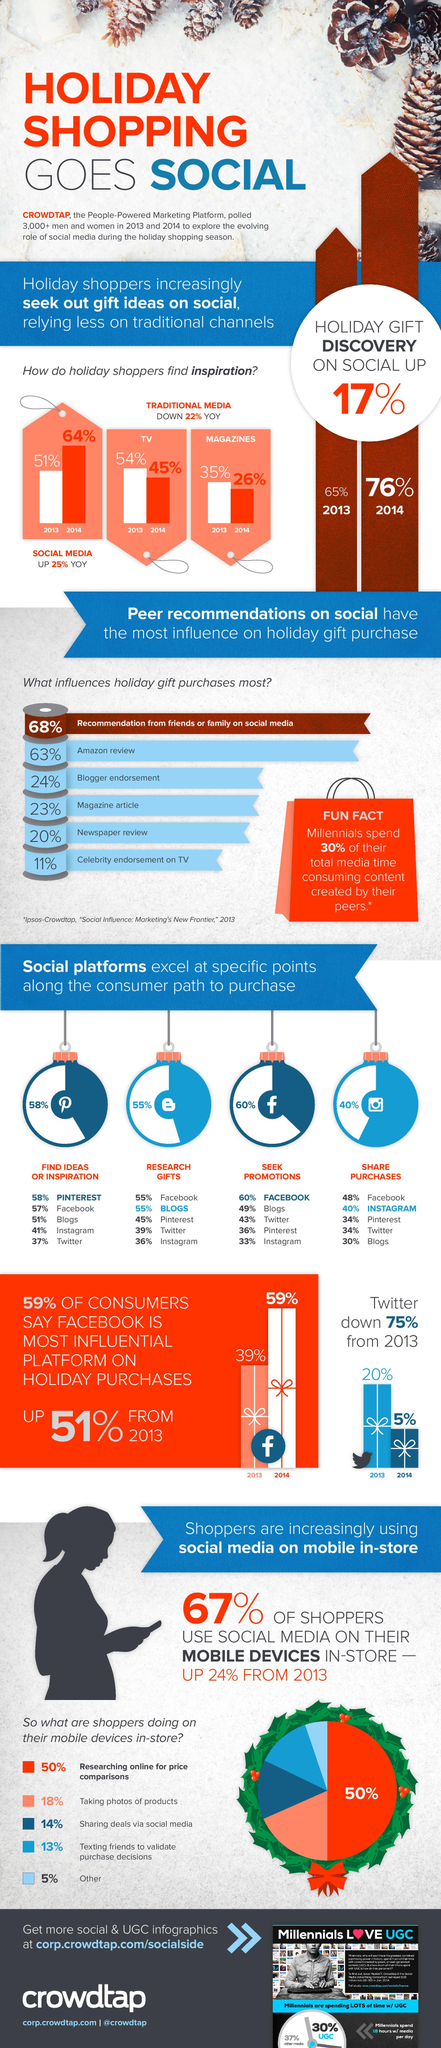Draw attention to some important aspects in this diagram. In 2013, 54% of holiday shoppers found inspiration for their gift purchases through TV, according to a survey conducted by a market research firm. According to data, Facebook is the most frequently used social media platform for sharing purchases. The top three social platforms used by consumers for finding ideas or inspiration for shopping are Pinterest, Facebook, and blogs. In 2013, the two primary traditional channels used by holiday shoppers were television and magazines. In 2014, a significant percentage of shoppers purchased holiday gifts on social media. Specifically, 76% of shoppers purchased gifts through social media channels. 